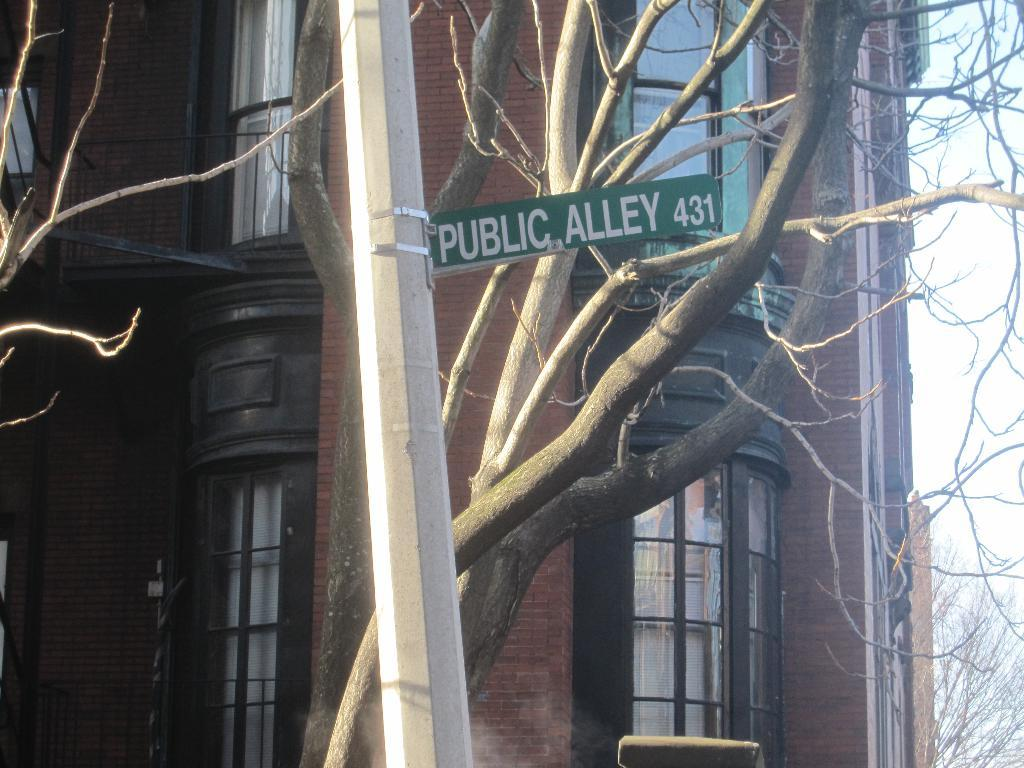What is the main object in the foreground of the image? There is a pole with a sign board in the image. What can be seen in the background of the image? There are trees and a building with windows in the background of the image. What is visible on the right side of the image? The sky is visible on the right side of the image, and there is also a tree on the right side of the image. What type of farm animals can be seen grazing in the image? There are no farm animals present in the image; it features a pole with a sign board, trees, a building, and the sky. Is there a baseball game taking place in the image? There is no baseball game present in the image; it does not depict any sports or athletic activities. 